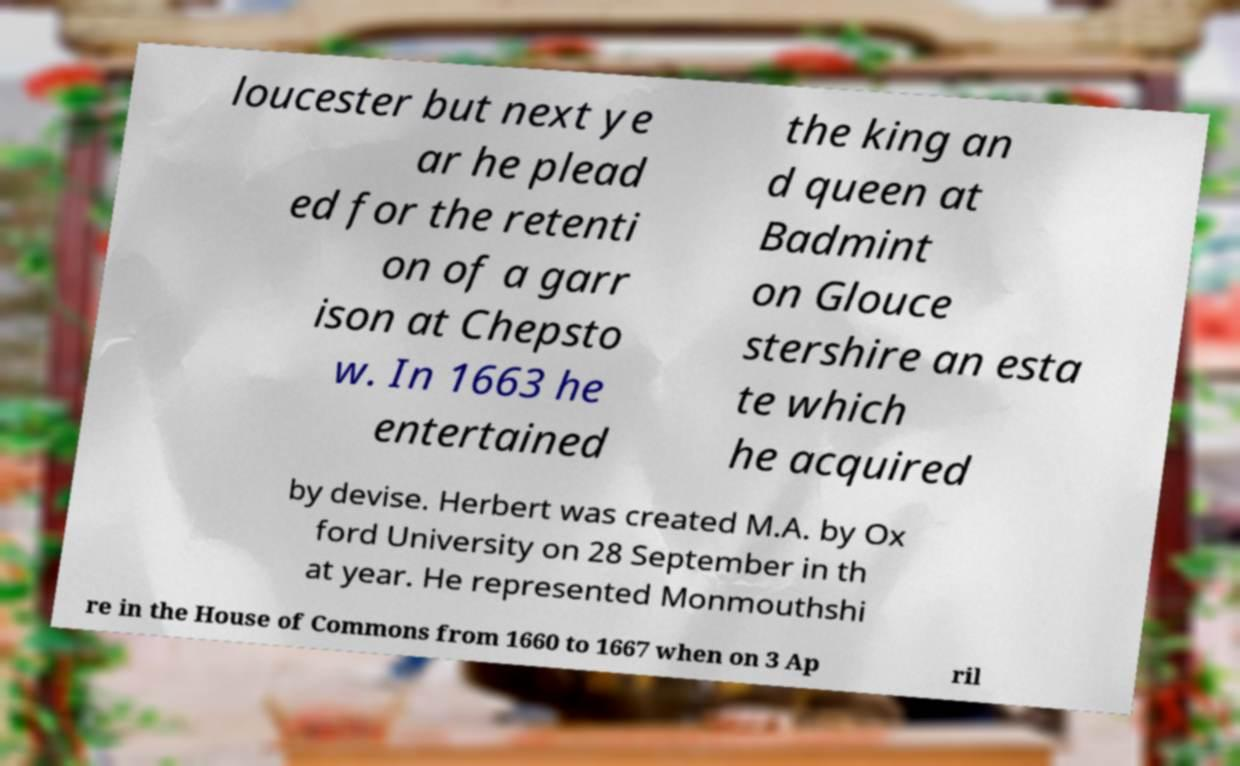Could you extract and type out the text from this image? loucester but next ye ar he plead ed for the retenti on of a garr ison at Chepsto w. In 1663 he entertained the king an d queen at Badmint on Glouce stershire an esta te which he acquired by devise. Herbert was created M.A. by Ox ford University on 28 September in th at year. He represented Monmouthshi re in the House of Commons from 1660 to 1667 when on 3 Ap ril 